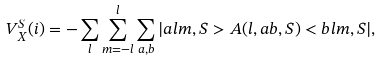<formula> <loc_0><loc_0><loc_500><loc_500>V _ { X } ^ { S } ( i ) = - \sum _ { l } \sum _ { m = - l } ^ { l } \sum _ { a , b } | a l m , S > A ( l , a b , S ) < b l m , S | ,</formula> 